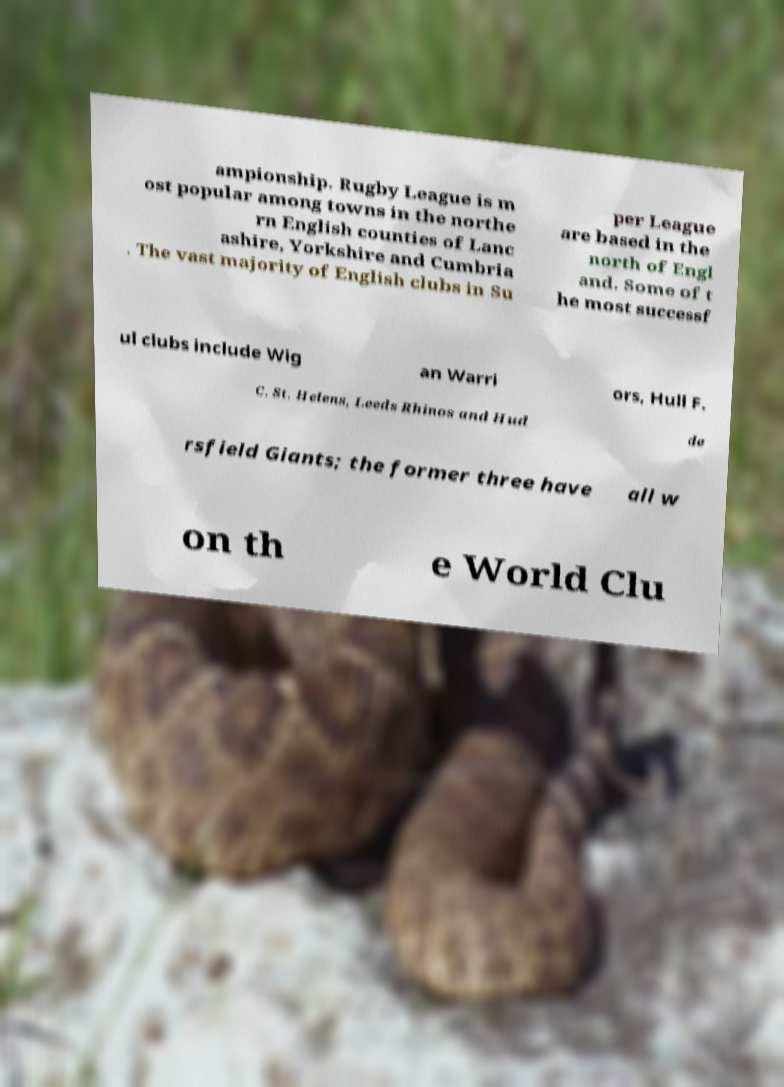Can you accurately transcribe the text from the provided image for me? ampionship. Rugby League is m ost popular among towns in the northe rn English counties of Lanc ashire, Yorkshire and Cumbria . The vast majority of English clubs in Su per League are based in the north of Engl and. Some of t he most successf ul clubs include Wig an Warri ors, Hull F. C. St. Helens, Leeds Rhinos and Hud de rsfield Giants; the former three have all w on th e World Clu 